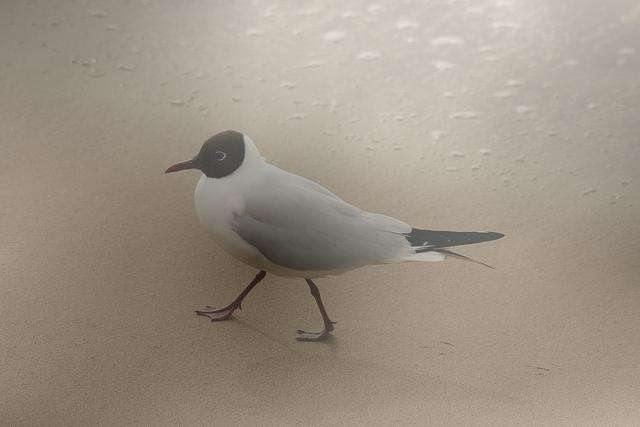What time of day does this setting suggest? The image has a soft, diffuse light and muted colors, suggesting that it could be either early morning or late afternoon, often referred to as the 'golden hours' which are known for their soft lighting and potential for beautiful photography. 